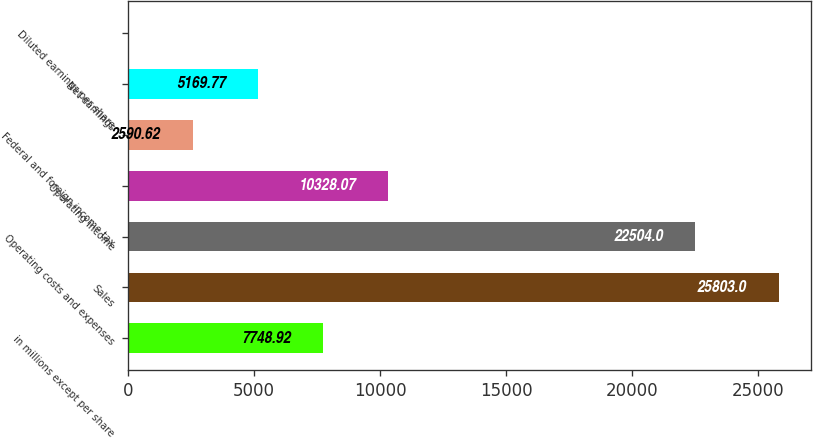Convert chart to OTSL. <chart><loc_0><loc_0><loc_500><loc_500><bar_chart><fcel>in millions except per share<fcel>Sales<fcel>Operating costs and expenses<fcel>Operating income<fcel>Federal and foreign income tax<fcel>Net earnings<fcel>Diluted earnings per share<nl><fcel>7748.92<fcel>25803<fcel>22504<fcel>10328.1<fcel>2590.62<fcel>5169.77<fcel>11.47<nl></chart> 